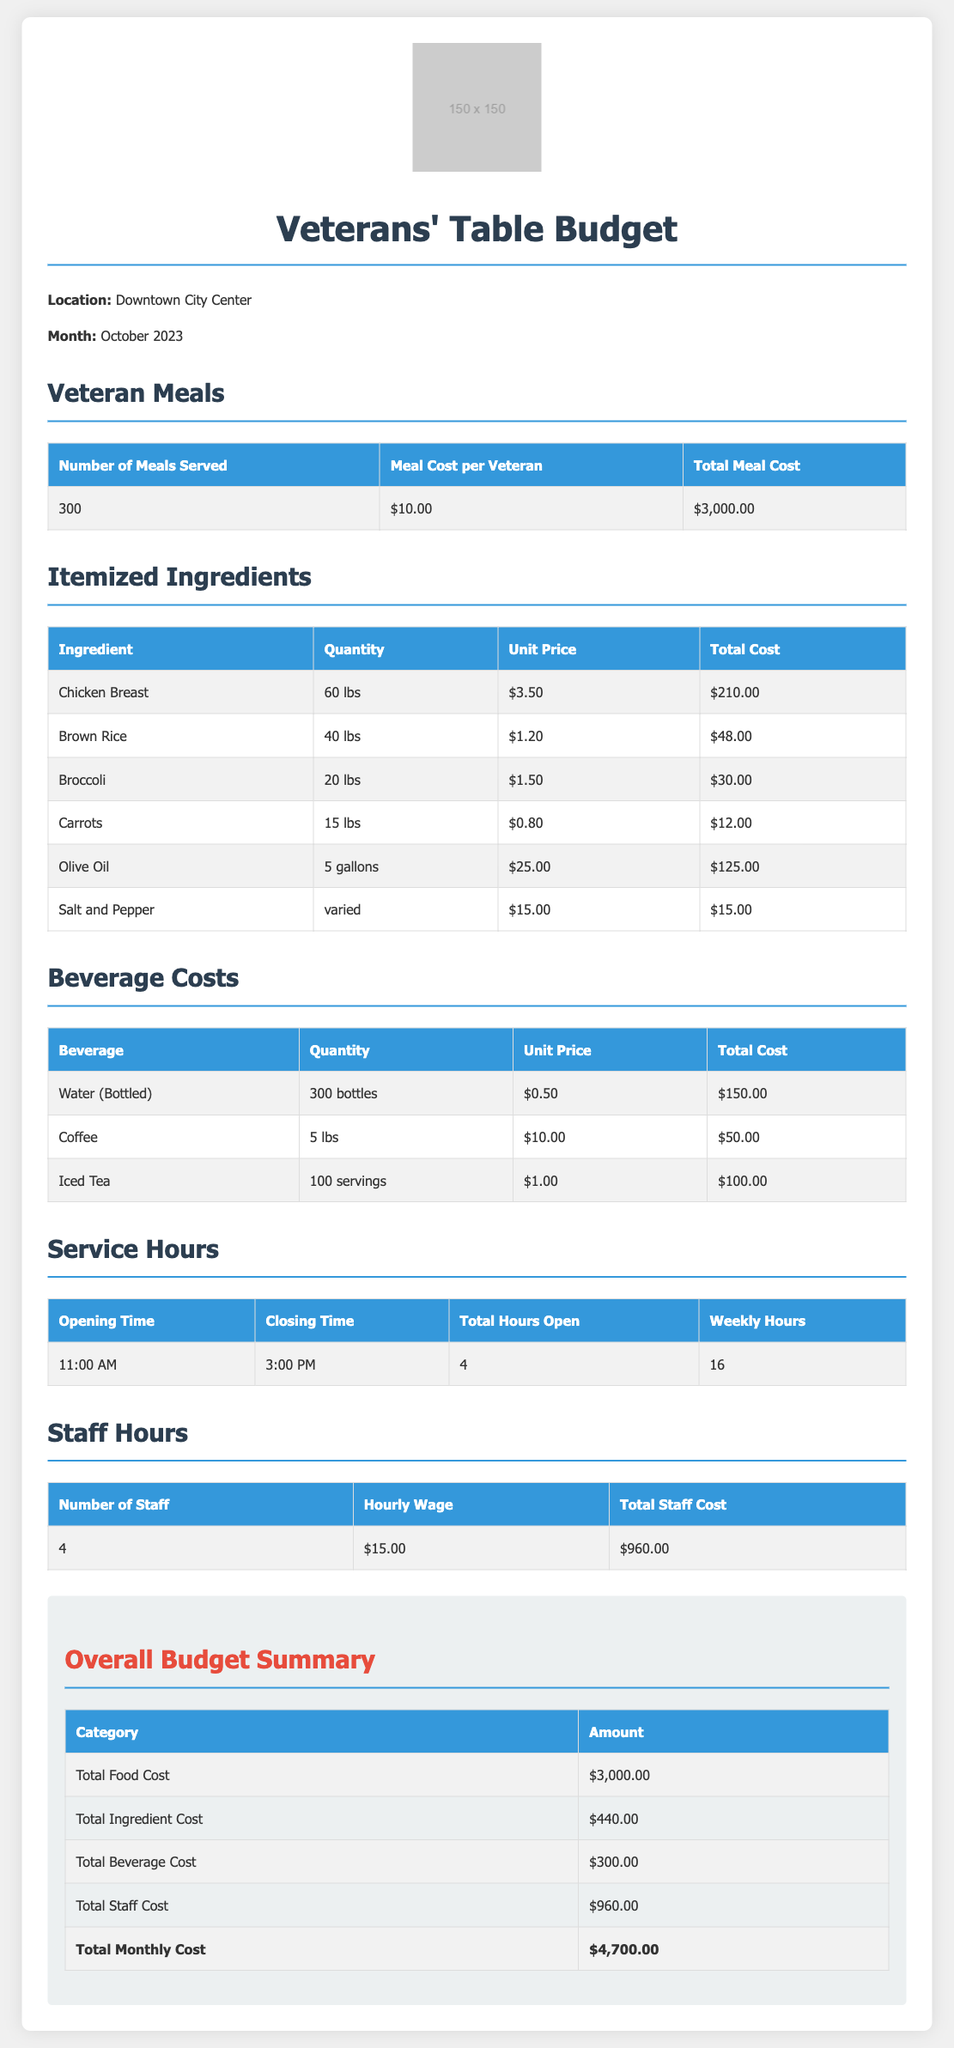What is the total number of meals served? The total number of meals served is stated in the document under "Veteran Meals" as 300.
Answer: 300 What is the cost of chicken breast? The cost of chicken breast is listed under "Itemized Ingredients" as $210.00.
Answer: $210.00 How many pounds of brown rice were used? The quantity of brown rice is mentioned in the "Itemized Ingredients" section as 40 lbs.
Answer: 40 lbs What is the total beverage cost? The total beverage cost is detailed in the "Overall Budget Summary" as $300.00.
Answer: $300.00 How many hours is the restaurant open per week? The total hours the restaurant is open weekly is provided in "Service Hours" as 16.
Answer: 16 What is the hourly wage for staff? The document states the hourly wage for staff in the "Staff Hours" section as $15.00.
Answer: $15.00 What is the total monthly cost? The total monthly cost is summed up in the "Overall Budget Summary" as $4,700.00.
Answer: $4,700.00 What ingredient has the highest total cost? The ingredient with the highest total cost, according to the "Itemized Ingredients" table, is Olive Oil with a total cost of $125.00.
Answer: Olive Oil How many staff members are employed? The number of staff is noted in the "Staff Hours" table as 4.
Answer: 4 What is the total meal cost per veteran? The total meal cost per veteran is specified in the "Veteran Meals" section as $10.00.
Answer: $10.00 